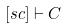Convert formula to latex. <formula><loc_0><loc_0><loc_500><loc_500>[ s c ] \vdash C</formula> 